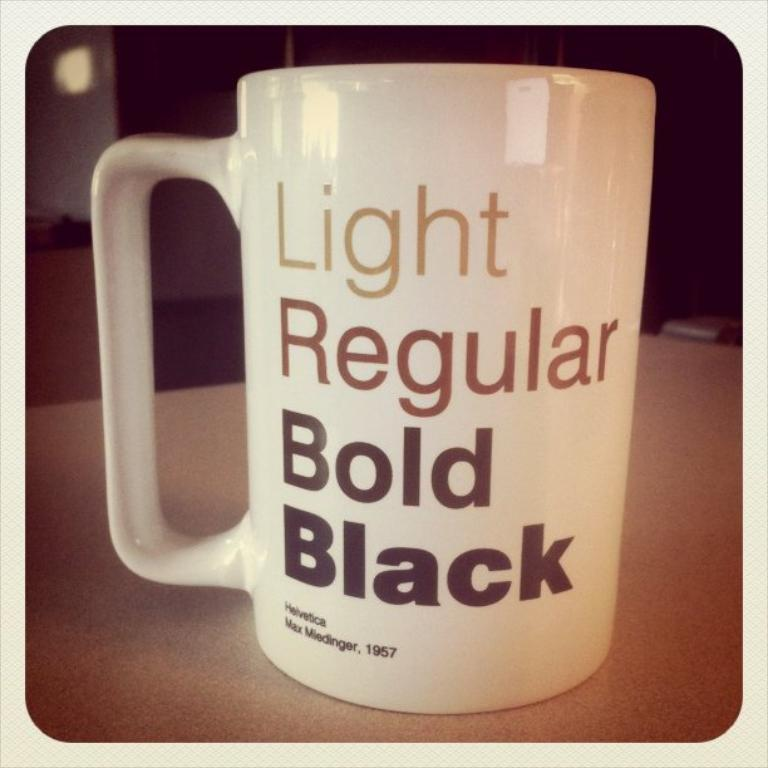<image>
Present a compact description of the photo's key features. white coffee mug that read light regular bold black 